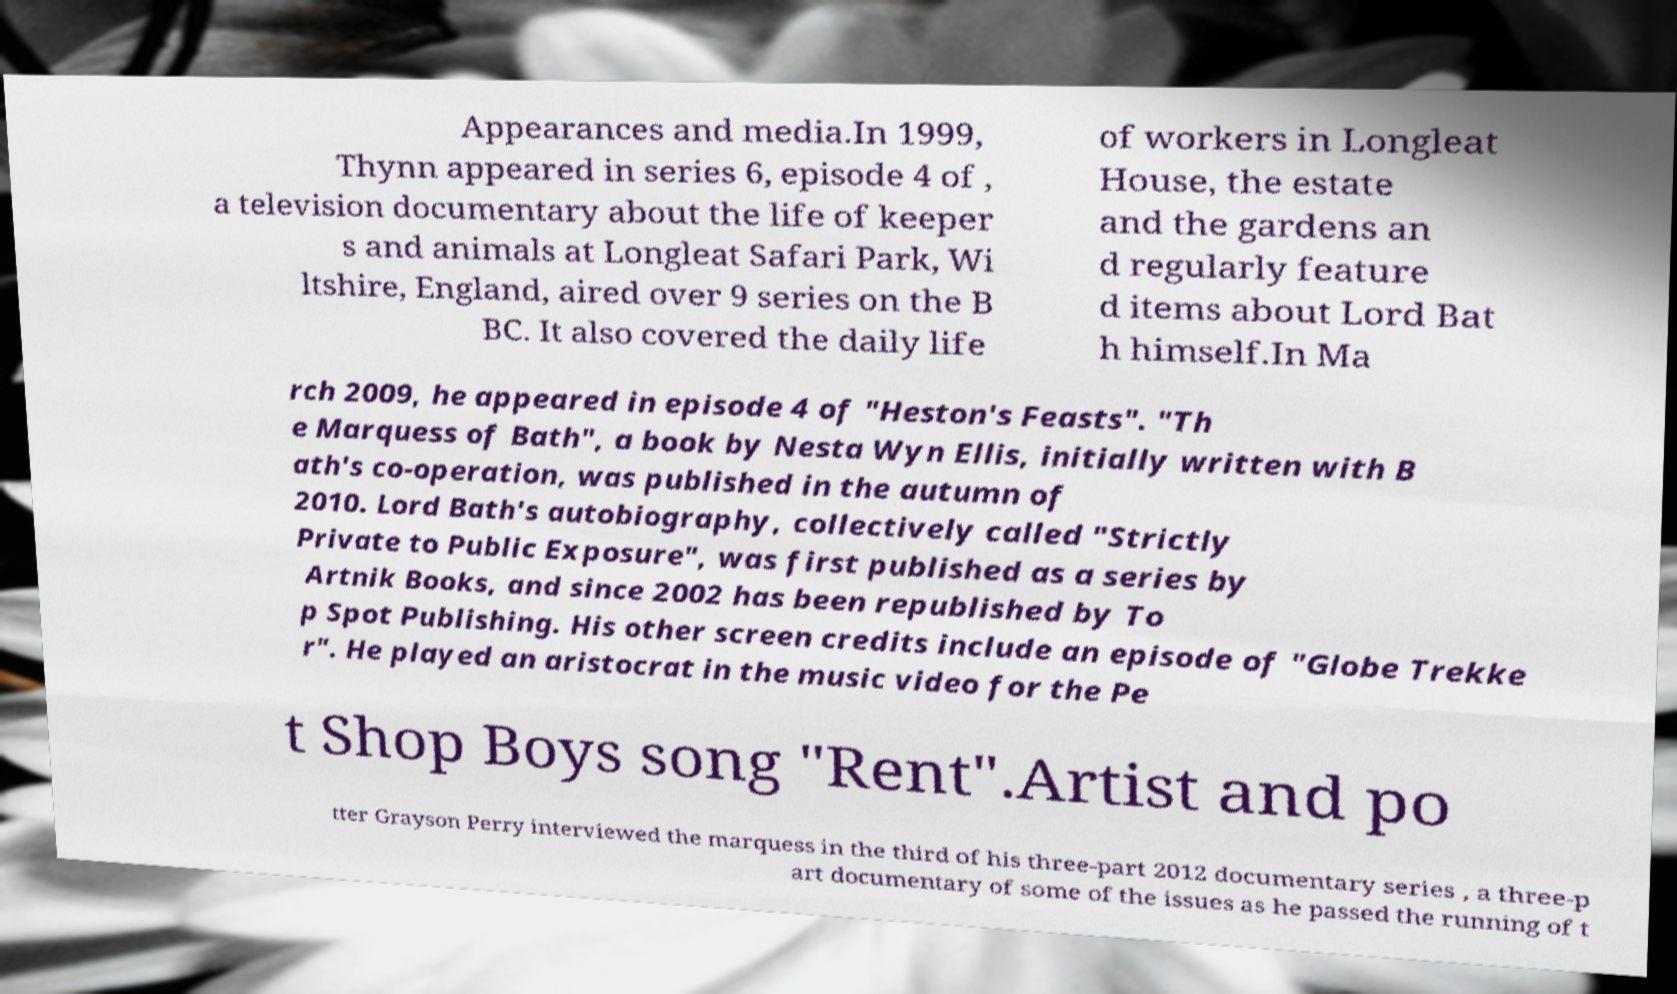Could you extract and type out the text from this image? Appearances and media.In 1999, Thynn appeared in series 6, episode 4 of , a television documentary about the life of keeper s and animals at Longleat Safari Park, Wi ltshire, England, aired over 9 series on the B BC. It also covered the daily life of workers in Longleat House, the estate and the gardens an d regularly feature d items about Lord Bat h himself.In Ma rch 2009, he appeared in episode 4 of "Heston's Feasts". "Th e Marquess of Bath", a book by Nesta Wyn Ellis, initially written with B ath's co-operation, was published in the autumn of 2010. Lord Bath's autobiography, collectively called "Strictly Private to Public Exposure", was first published as a series by Artnik Books, and since 2002 has been republished by To p Spot Publishing. His other screen credits include an episode of "Globe Trekke r". He played an aristocrat in the music video for the Pe t Shop Boys song "Rent".Artist and po tter Grayson Perry interviewed the marquess in the third of his three-part 2012 documentary series , a three-p art documentary of some of the issues as he passed the running of t 